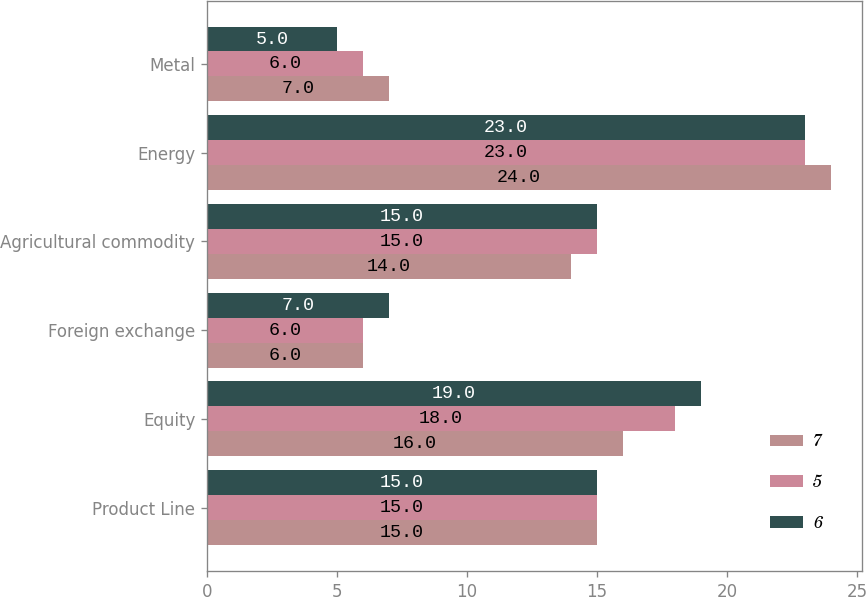Convert chart to OTSL. <chart><loc_0><loc_0><loc_500><loc_500><stacked_bar_chart><ecel><fcel>Product Line<fcel>Equity<fcel>Foreign exchange<fcel>Agricultural commodity<fcel>Energy<fcel>Metal<nl><fcel>7<fcel>15<fcel>16<fcel>6<fcel>14<fcel>24<fcel>7<nl><fcel>5<fcel>15<fcel>18<fcel>6<fcel>15<fcel>23<fcel>6<nl><fcel>6<fcel>15<fcel>19<fcel>7<fcel>15<fcel>23<fcel>5<nl></chart> 